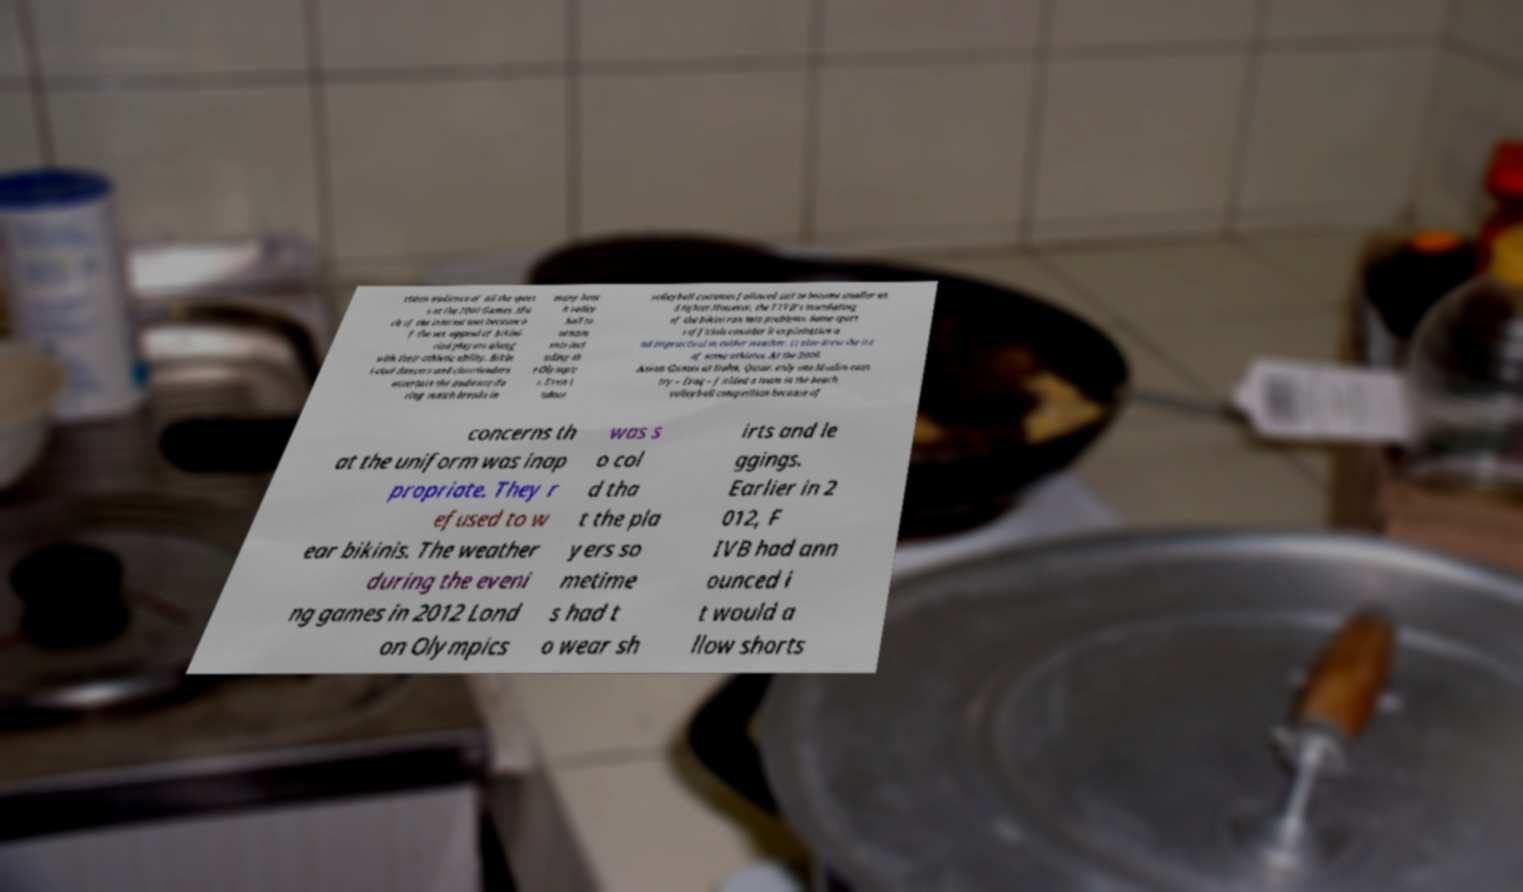For documentation purposes, I need the text within this image transcribed. Could you provide that? vision audience of all the sport s at the 2000 Games. Mu ch of the interest was because o f the sex appeal of bikini- clad players along with their athletic ability. Bikin i-clad dancers and cheerleaders entertain the audience du ring match breaks in many beac h volley ball to urnam ents incl uding th e Olympic s. Even i ndoor volleyball costumes followed suit to become smaller an d tighter.However, the FIVB's mandating of the bikini ran into problems. Some sport s officials consider it exploitative a nd impractical in colder weather. It also drew the ire of some athletes. At the 2006 Asian Games at Doha, Qatar, only one Muslim coun try – Iraq – fielded a team in the beach volleyball competition because of concerns th at the uniform was inap propriate. They r efused to w ear bikinis. The weather during the eveni ng games in 2012 Lond on Olympics was s o col d tha t the pla yers so metime s had t o wear sh irts and le ggings. Earlier in 2 012, F IVB had ann ounced i t would a llow shorts 